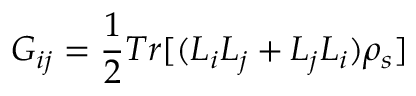Convert formula to latex. <formula><loc_0><loc_0><loc_500><loc_500>G _ { i j } = \frac { 1 } { 2 } T r [ ( L _ { i } L _ { j } + L _ { j } L _ { i } ) \rho _ { s } ]</formula> 